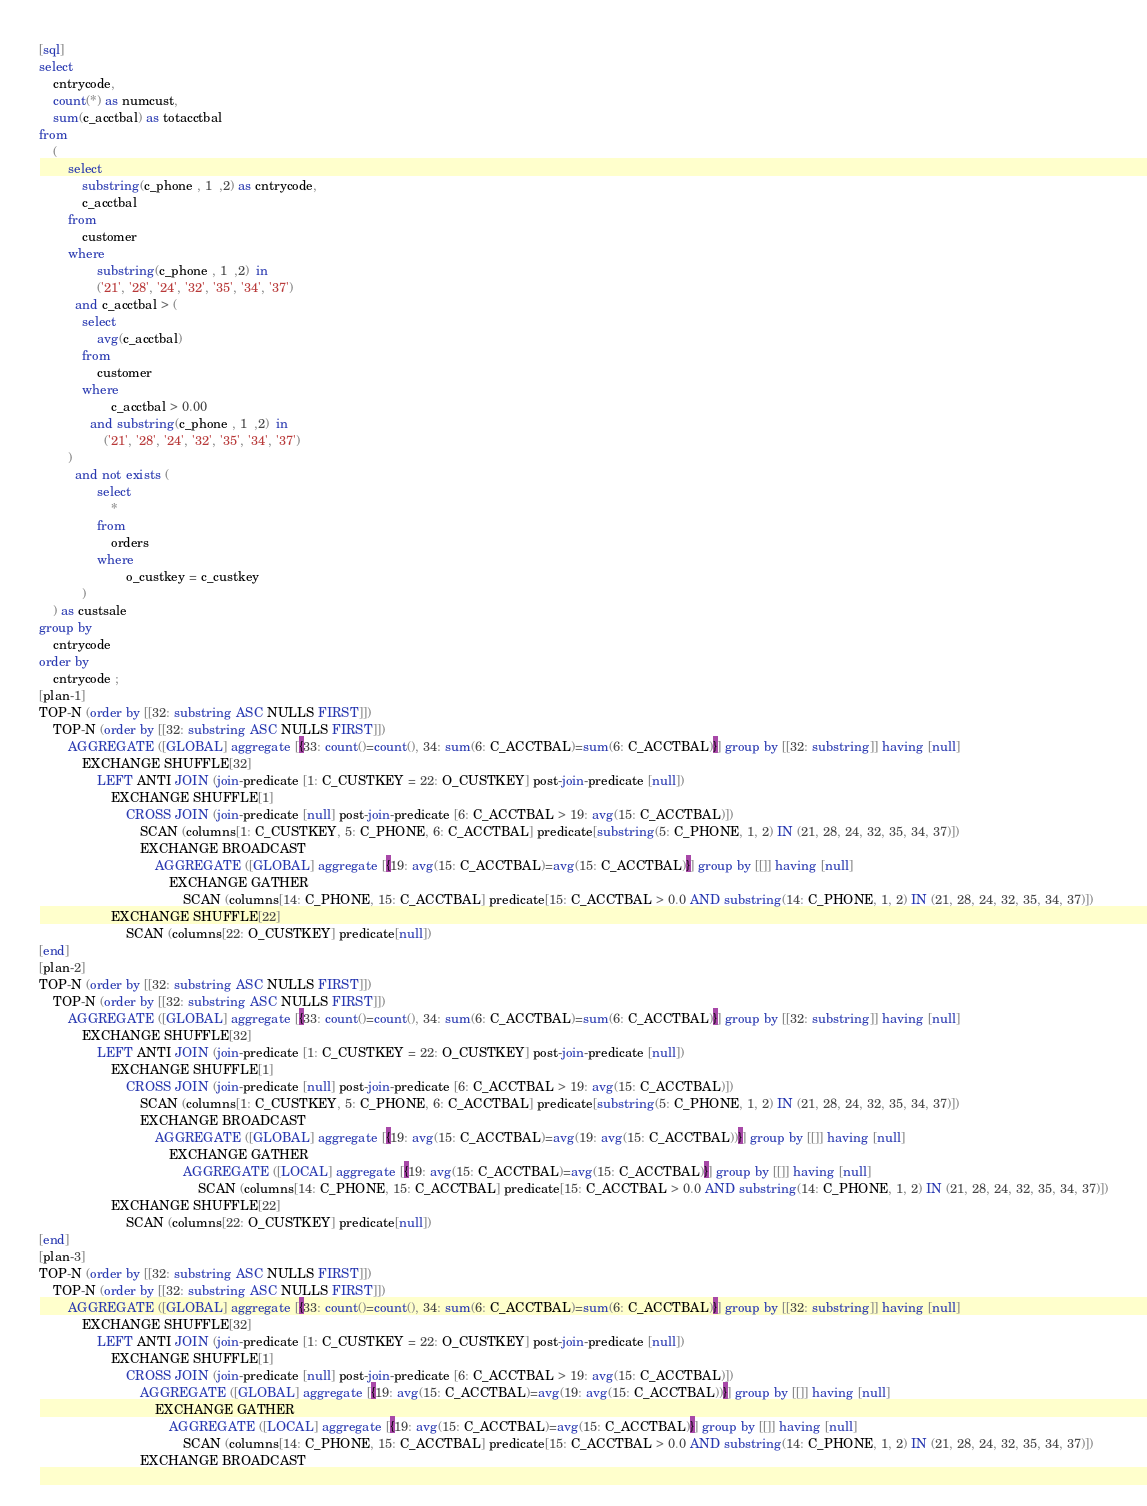Convert code to text. <code><loc_0><loc_0><loc_500><loc_500><_SQL_>[sql]
select
    cntrycode,
    count(*) as numcust,
    sum(c_acctbal) as totacctbal
from
    (
        select
            substring(c_phone , 1  ,2) as cntrycode,
            c_acctbal
        from
            customer
        where
                substring(c_phone , 1  ,2)  in
                ('21', '28', '24', '32', '35', '34', '37')
          and c_acctbal > (
            select
                avg(c_acctbal)
            from
                customer
            where
                    c_acctbal > 0.00
              and substring(c_phone , 1  ,2)  in
                  ('21', '28', '24', '32', '35', '34', '37')
        )
          and not exists (
                select
                    *
                from
                    orders
                where
                        o_custkey = c_custkey
            )
    ) as custsale
group by
    cntrycode
order by
    cntrycode ;
[plan-1]
TOP-N (order by [[32: substring ASC NULLS FIRST]])
    TOP-N (order by [[32: substring ASC NULLS FIRST]])
        AGGREGATE ([GLOBAL] aggregate [{33: count()=count(), 34: sum(6: C_ACCTBAL)=sum(6: C_ACCTBAL)}] group by [[32: substring]] having [null]
            EXCHANGE SHUFFLE[32]
                LEFT ANTI JOIN (join-predicate [1: C_CUSTKEY = 22: O_CUSTKEY] post-join-predicate [null])
                    EXCHANGE SHUFFLE[1]
                        CROSS JOIN (join-predicate [null] post-join-predicate [6: C_ACCTBAL > 19: avg(15: C_ACCTBAL)])
                            SCAN (columns[1: C_CUSTKEY, 5: C_PHONE, 6: C_ACCTBAL] predicate[substring(5: C_PHONE, 1, 2) IN (21, 28, 24, 32, 35, 34, 37)])
                            EXCHANGE BROADCAST
                                AGGREGATE ([GLOBAL] aggregate [{19: avg(15: C_ACCTBAL)=avg(15: C_ACCTBAL)}] group by [[]] having [null]
                                    EXCHANGE GATHER
                                        SCAN (columns[14: C_PHONE, 15: C_ACCTBAL] predicate[15: C_ACCTBAL > 0.0 AND substring(14: C_PHONE, 1, 2) IN (21, 28, 24, 32, 35, 34, 37)])
                    EXCHANGE SHUFFLE[22]
                        SCAN (columns[22: O_CUSTKEY] predicate[null])
[end]
[plan-2]
TOP-N (order by [[32: substring ASC NULLS FIRST]])
    TOP-N (order by [[32: substring ASC NULLS FIRST]])
        AGGREGATE ([GLOBAL] aggregate [{33: count()=count(), 34: sum(6: C_ACCTBAL)=sum(6: C_ACCTBAL)}] group by [[32: substring]] having [null]
            EXCHANGE SHUFFLE[32]
                LEFT ANTI JOIN (join-predicate [1: C_CUSTKEY = 22: O_CUSTKEY] post-join-predicate [null])
                    EXCHANGE SHUFFLE[1]
                        CROSS JOIN (join-predicate [null] post-join-predicate [6: C_ACCTBAL > 19: avg(15: C_ACCTBAL)])
                            SCAN (columns[1: C_CUSTKEY, 5: C_PHONE, 6: C_ACCTBAL] predicate[substring(5: C_PHONE, 1, 2) IN (21, 28, 24, 32, 35, 34, 37)])
                            EXCHANGE BROADCAST
                                AGGREGATE ([GLOBAL] aggregate [{19: avg(15: C_ACCTBAL)=avg(19: avg(15: C_ACCTBAL))}] group by [[]] having [null]
                                    EXCHANGE GATHER
                                        AGGREGATE ([LOCAL] aggregate [{19: avg(15: C_ACCTBAL)=avg(15: C_ACCTBAL)}] group by [[]] having [null]
                                            SCAN (columns[14: C_PHONE, 15: C_ACCTBAL] predicate[15: C_ACCTBAL > 0.0 AND substring(14: C_PHONE, 1, 2) IN (21, 28, 24, 32, 35, 34, 37)])
                    EXCHANGE SHUFFLE[22]
                        SCAN (columns[22: O_CUSTKEY] predicate[null])
[end]
[plan-3]
TOP-N (order by [[32: substring ASC NULLS FIRST]])
    TOP-N (order by [[32: substring ASC NULLS FIRST]])
        AGGREGATE ([GLOBAL] aggregate [{33: count()=count(), 34: sum(6: C_ACCTBAL)=sum(6: C_ACCTBAL)}] group by [[32: substring]] having [null]
            EXCHANGE SHUFFLE[32]
                LEFT ANTI JOIN (join-predicate [1: C_CUSTKEY = 22: O_CUSTKEY] post-join-predicate [null])
                    EXCHANGE SHUFFLE[1]
                        CROSS JOIN (join-predicate [null] post-join-predicate [6: C_ACCTBAL > 19: avg(15: C_ACCTBAL)])
                            AGGREGATE ([GLOBAL] aggregate [{19: avg(15: C_ACCTBAL)=avg(19: avg(15: C_ACCTBAL))}] group by [[]] having [null]
                                EXCHANGE GATHER
                                    AGGREGATE ([LOCAL] aggregate [{19: avg(15: C_ACCTBAL)=avg(15: C_ACCTBAL)}] group by [[]] having [null]
                                        SCAN (columns[14: C_PHONE, 15: C_ACCTBAL] predicate[15: C_ACCTBAL > 0.0 AND substring(14: C_PHONE, 1, 2) IN (21, 28, 24, 32, 35, 34, 37)])
                            EXCHANGE BROADCAST</code> 